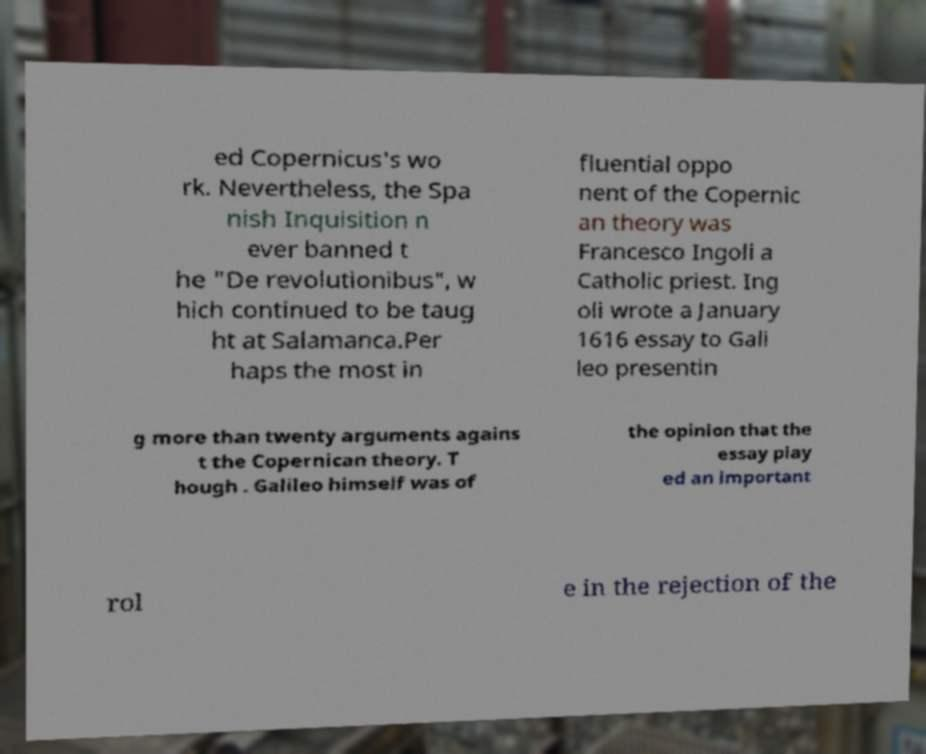Please read and relay the text visible in this image. What does it say? ed Copernicus's wo rk. Nevertheless, the Spa nish Inquisition n ever banned t he "De revolutionibus", w hich continued to be taug ht at Salamanca.Per haps the most in fluential oppo nent of the Copernic an theory was Francesco Ingoli a Catholic priest. Ing oli wrote a January 1616 essay to Gali leo presentin g more than twenty arguments agains t the Copernican theory. T hough . Galileo himself was of the opinion that the essay play ed an important rol e in the rejection of the 